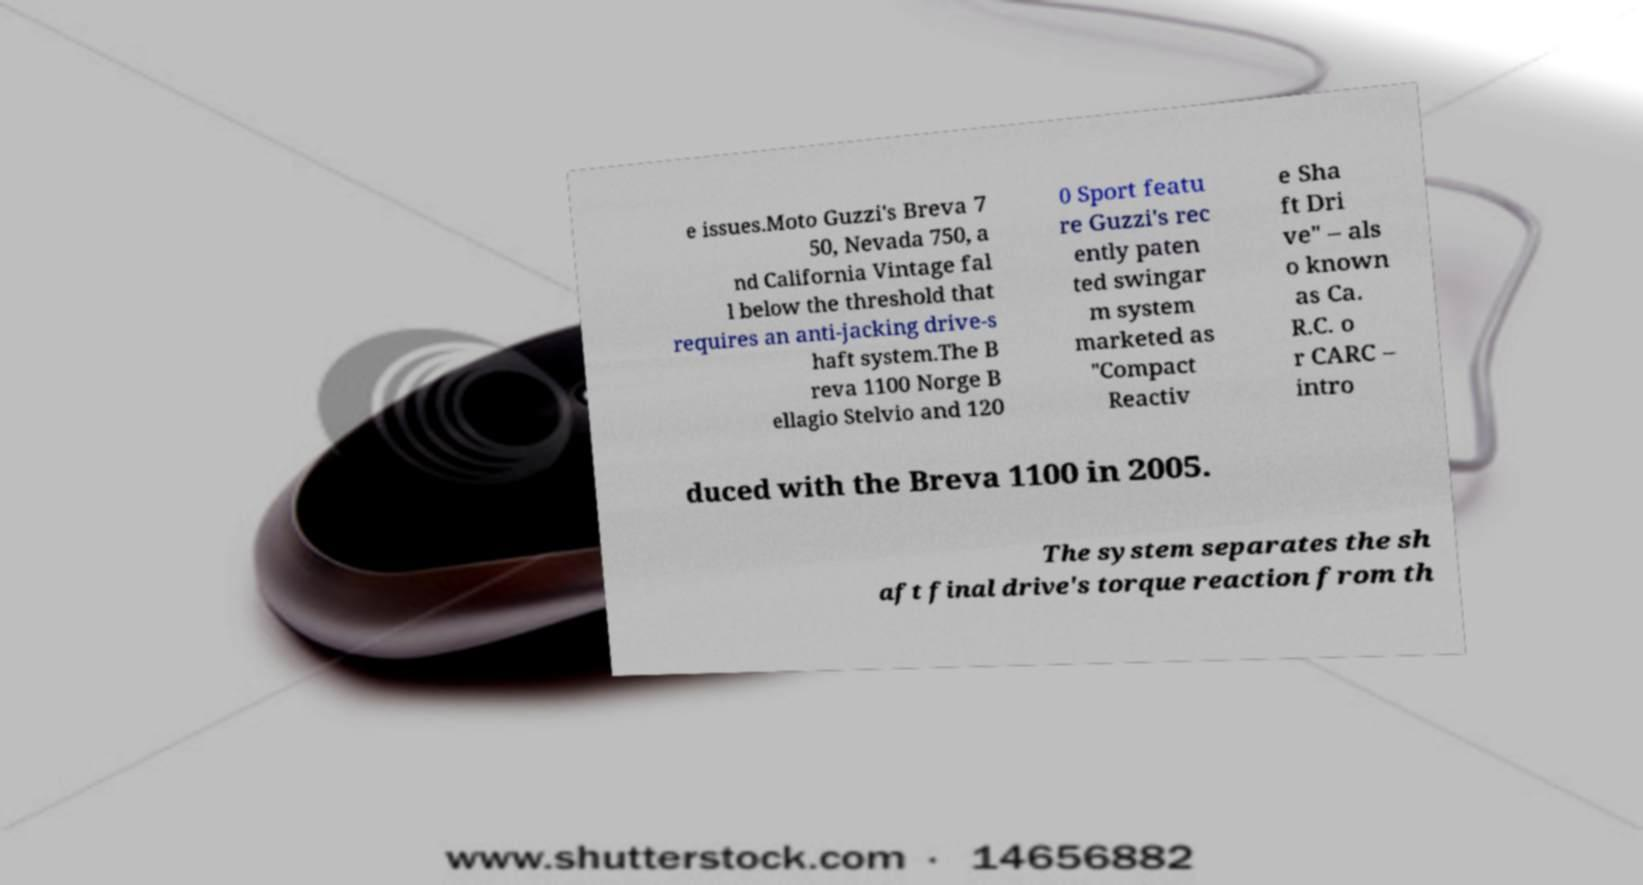Please identify and transcribe the text found in this image. e issues.Moto Guzzi's Breva 7 50, Nevada 750, a nd California Vintage fal l below the threshold that requires an anti-jacking drive-s haft system.The B reva 1100 Norge B ellagio Stelvio and 120 0 Sport featu re Guzzi's rec ently paten ted swingar m system marketed as "Compact Reactiv e Sha ft Dri ve" – als o known as Ca. R.C. o r CARC – intro duced with the Breva 1100 in 2005. The system separates the sh aft final drive's torque reaction from th 